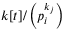<formula> <loc_0><loc_0><loc_500><loc_500>k [ t ] / \left ( p _ { i } ^ { k _ { j } } \right )</formula> 